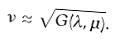Convert formula to latex. <formula><loc_0><loc_0><loc_500><loc_500>\nu \approx \sqrt { G ( \lambda , \mu ) } .</formula> 